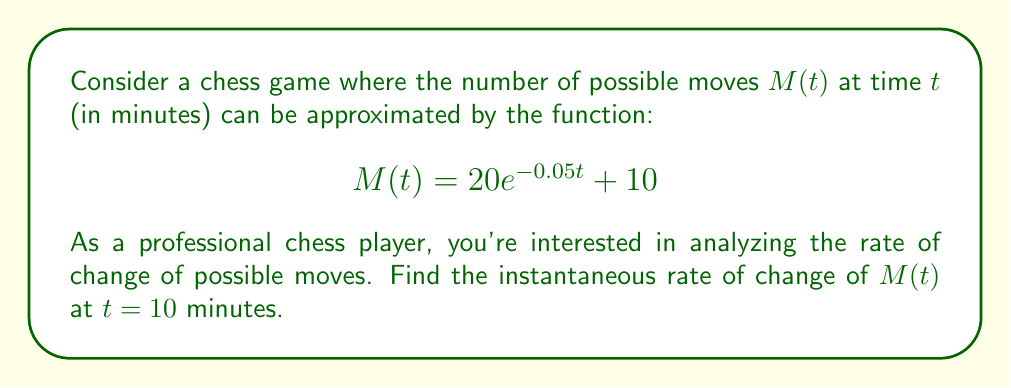Teach me how to tackle this problem. To find the instantaneous rate of change of $M(t)$ at $t = 10$ minutes, we need to calculate the derivative of $M(t)$ and evaluate it at $t = 10$.

Step 1: Find the derivative of $M(t)$.
$$\frac{d}{dt}M(t) = \frac{d}{dt}(20e^{-0.05t} + 10)$$
$$M'(t) = 20 \cdot (-0.05)e^{-0.05t} + 0$$
$$M'(t) = -e^{-0.05t}$$

Step 2: Evaluate $M'(t)$ at $t = 10$.
$$M'(10) = -e^{-0.05(10)}$$
$$M'(10) = -e^{-0.5}$$
$$M'(10) \approx -0.6065$$

Step 3: Interpret the result.
The negative value indicates that the number of possible moves is decreasing at $t = 10$ minutes. The rate of change is approximately -0.6065 moves per minute.
Answer: $-e^{-0.5} \approx -0.6065$ moves/minute 